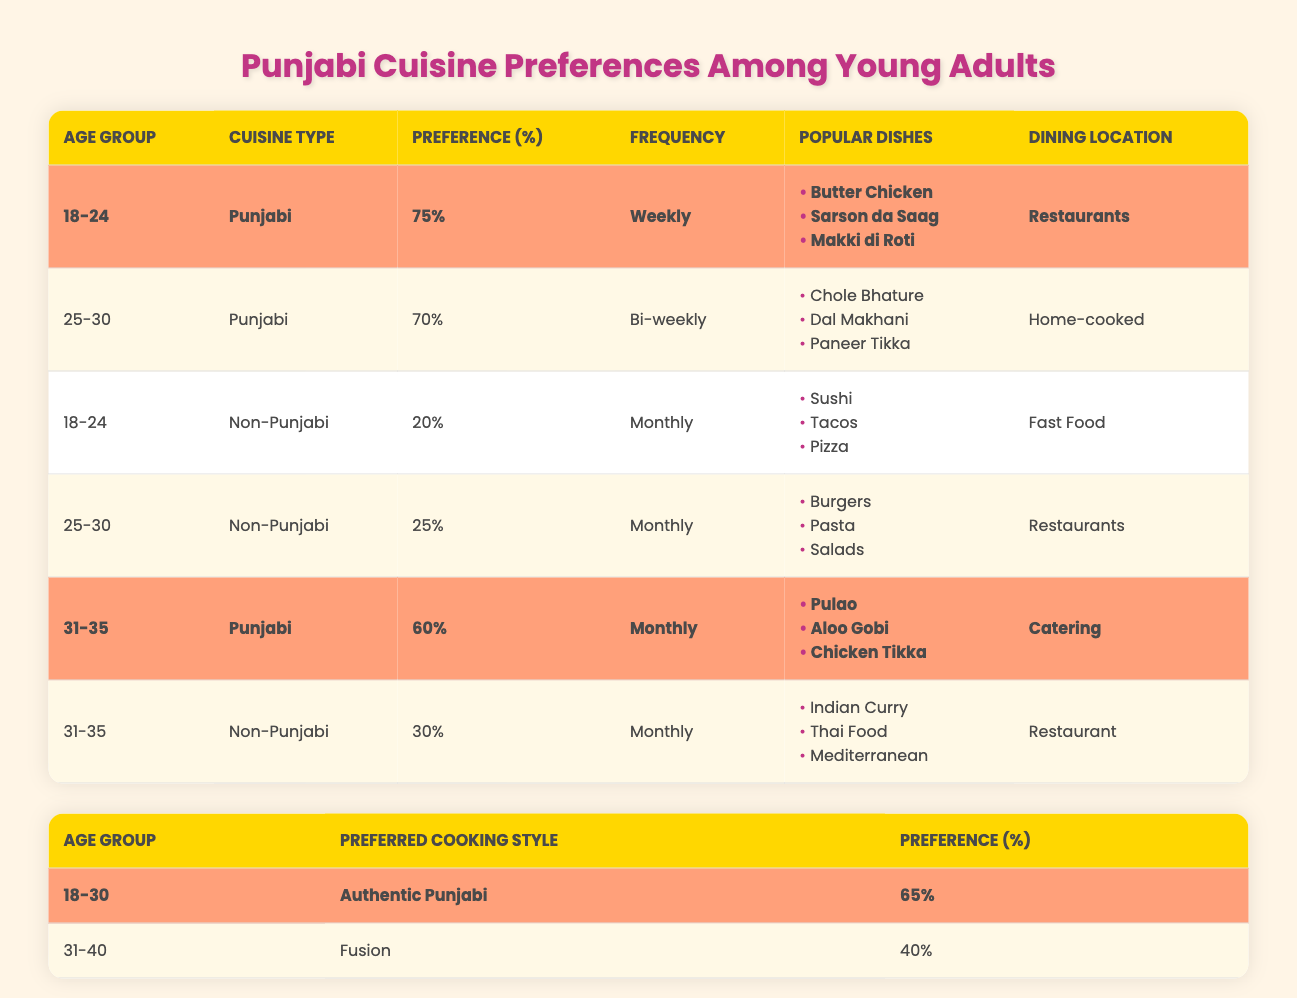What is the preference percentage for Punjabi cuisine among 18-24 year-olds? According to the table, the preference percentage for Punjabi cuisine among 18-24 year-olds is 75%.
Answer: 75% How many age groups show a higher preference for Punjabi cuisine compared to Non-Punjabi cuisine? Two age groups (18-24 and 31-35) show a higher preference for Punjabi cuisine (75% and 60%) compared to the Non-Punjabi cuisine preferences of the same age groups (20% and 30%, respectively).
Answer: 2 What is the preferred cooking style with the highest percentage preference? The preferred cooking style with the highest percentage preference is "Authentic Punjabi," which has a preference of 65%.
Answer: Authentic Punjabi Which age group prefers Non-Punjabi cuisine the least? The age group that prefers Non-Punjabi cuisine the least is the 18-24 age group, with a preference percentage of 20%.
Answer: 18-24 Is there any age group that prefers Punjabi cuisine weekly? Yes, the 18-24 age group prefers Punjabi cuisine weekly, as specified in the frequency column for their preference.
Answer: Yes What is the average preference percentage for Punjabi cuisine among the highlighted age groups? The highlighted age groups for Punjabi cuisine preferences are 18-24 (75%) and 31-35 (60%), so the average is (75 + 60) / 2 = 67.5%.
Answer: 67.5% How does the frequency of Punjabi cuisine consumption differ between the 18-24 and 25-30 age groups? The 18-24 age group consumes Punjabi cuisine weekly, while the 25-30 age group consumes it bi-weekly, indicating that the younger group eats it more often.
Answer: The 18-24 group eats it more often What is the percentage difference in preference for Authentic Punjabi cooking between the age groups 18-30 and 31-40? The preference for Authentic Punjabi cooking is 65% for 18-30 and 40% for 31-40, making the difference 65% - 40% = 25%.
Answer: 25% Which age group prefers dining in restaurants most for Punjabi cuisine? The 18-24 age group prefers dining in restaurants most for Punjabi cuisine, as their dining location is listed as restaurants.
Answer: 18-24 In which age group is the preference for Non-Punjabi cuisine higher than that for Punjabi cuisine? The 25-30 age group prefers Non-Punjabi cuisine (25%) over Punjabi cuisine (70%), meaning they have a lower preference for Non-Punjabi cuisine.
Answer: None 